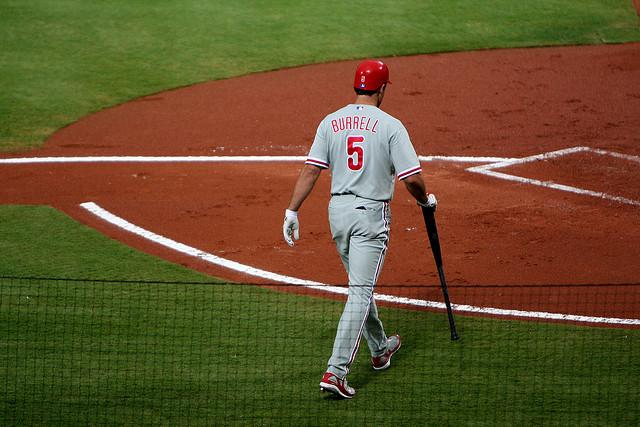Is he walking on the green?
Keep it brief. Yes. What brand are the man's shoes?
Answer briefly. Nike. What color is the man's helmet?
Quick response, please. Red. 